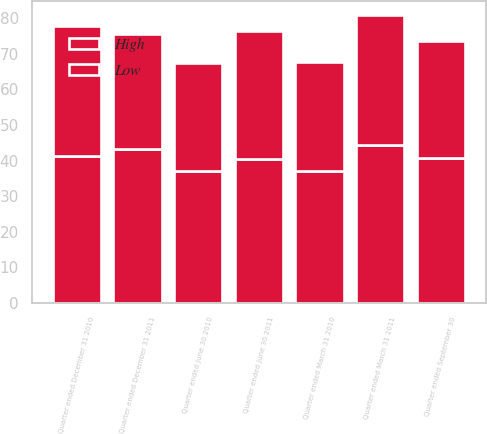Convert chart. <chart><loc_0><loc_0><loc_500><loc_500><stacked_bar_chart><ecel><fcel>Quarter ended December 31 2011<fcel>Quarter ended September 30<fcel>Quarter ended June 30 2011<fcel>Quarter ended March 31 2011<fcel>Quarter ended December 31 2010<fcel>Quarter ended June 30 2010<fcel>Quarter ended March 31 2010<nl><fcel>High<fcel>43.12<fcel>40.6<fcel>40.35<fcel>44.44<fcel>41.29<fcel>37.03<fcel>37.12<nl><fcel>Low<fcel>32.36<fcel>33.06<fcel>36.1<fcel>36.36<fcel>36.38<fcel>30.47<fcel>30.64<nl></chart> 